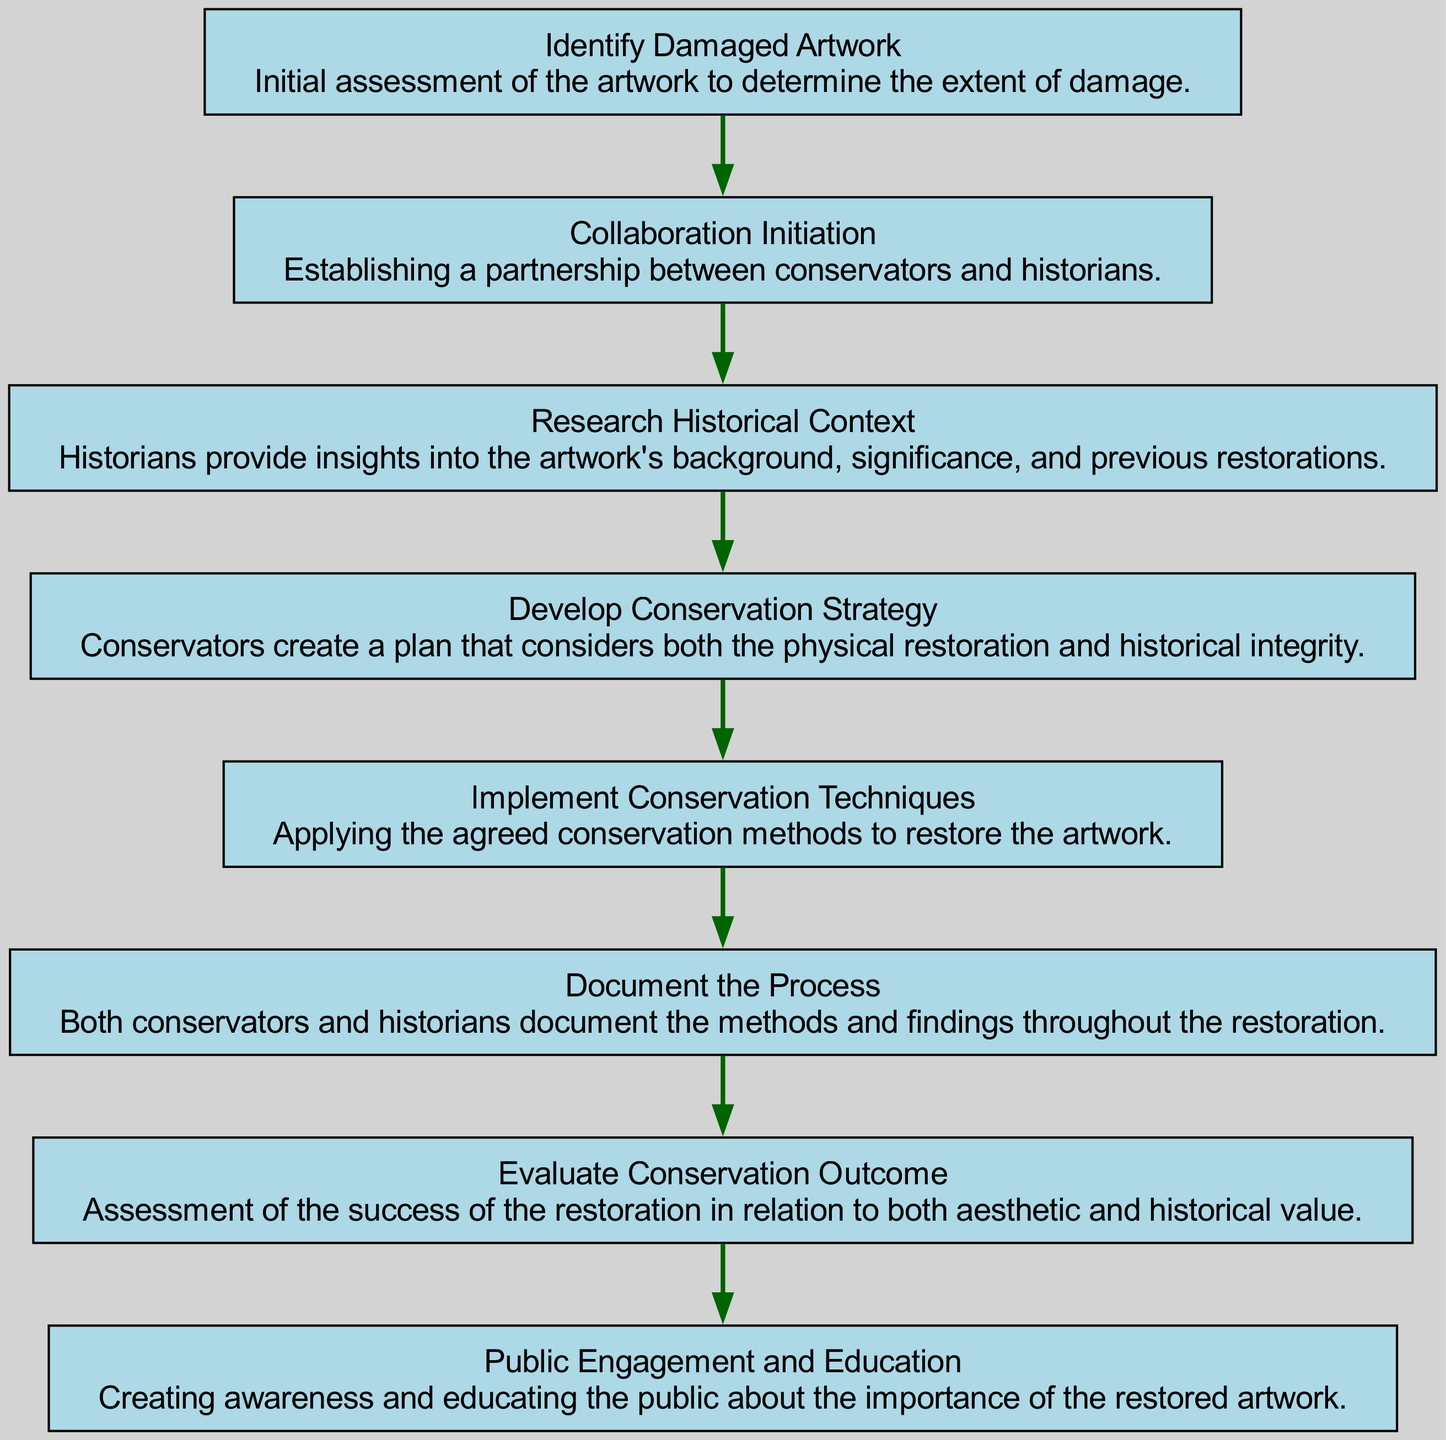What is the first step in the diagram? The first step is "Identify Damaged Artwork," which signifies the initial assessment of the artwork's damage. It is the first node listed in the diagram's flow, setting the stage for the subsequent actions.
Answer: Identify Damaged Artwork How many total nodes are there in the flowchart? The flowchart includes eight nodes, which represent the various stages in the collaborative process between conservators and historians. Each element in the data corresponds to one specific action or stage.
Answer: Eight Which node follows the "Collaboration Initiation" node? The node that follows "Collaboration Initiation" is "Research Historical Context." This progression depicts the next logical step after establishing a partnership, where historians provide insights into the artwork's background.
Answer: Research Historical Context What is the final step in the diagram? The final step is "Public Engagement and Education," which emphasizes the importance of educating the public about the restored artwork, highlighting its value in cultural heritage. It is the last node in the flowchart.
Answer: Public Engagement and Education How many edges connect the nodes in the diagram? There are seven edges in the diagram, connecting the eight nodes as they represent the flow of the conservation process from one step to another. Each edge signifies the progression from one action to the next.
Answer: Seven What two nodes are connected by the edge after "Implement Conservation Techniques"? The edge after "Implement Conservation Techniques" connects to "Document the Process." This illustrates that once conservation techniques are applied, the following action is to document the methods and findings of the restoration.
Answer: Document the Process What aspect do conservators consider when developing conservation strategy? Conservators consider both the physical restoration and historical integrity when developing the conservation strategy. This aspect is crucial to ensure that the artwork is preserved in its authentic context.
Answer: Physical restoration and historical integrity What role do historians play after the "Collaboration Initiation"? After the "Collaboration Initiation," historians provide insights into the artwork's background, which is addressed in the node "Research Historical Context." This step is critical in contextualizing the restoration efforts.
Answer: Insights into artwork's background 